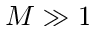<formula> <loc_0><loc_0><loc_500><loc_500>M \gg 1</formula> 